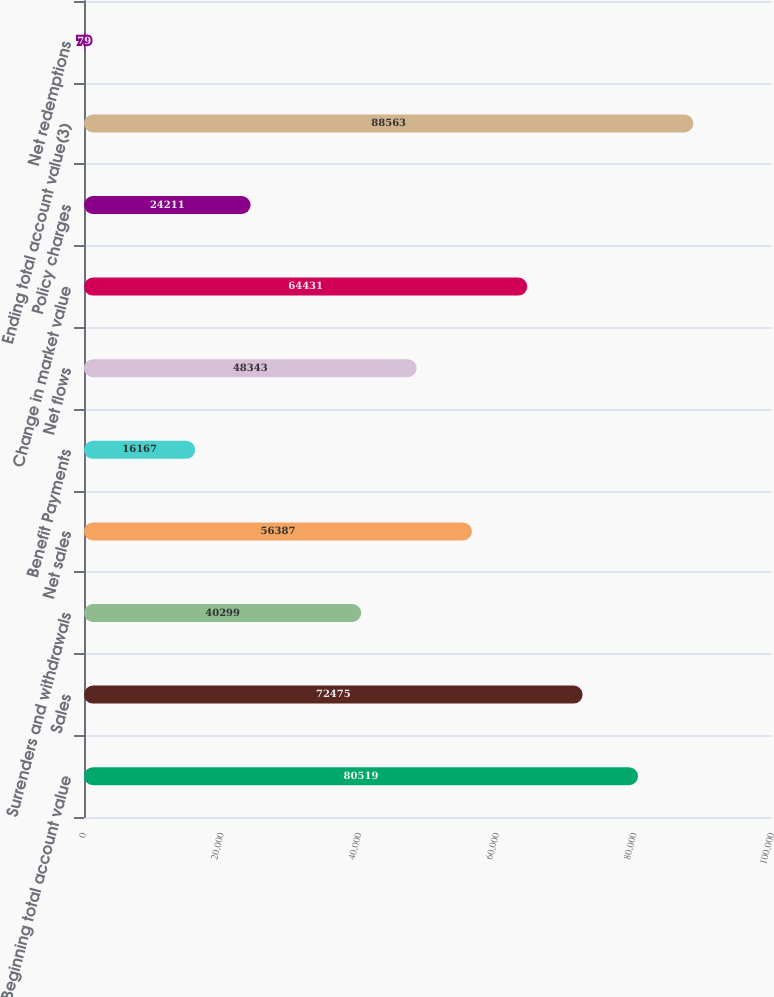Convert chart. <chart><loc_0><loc_0><loc_500><loc_500><bar_chart><fcel>Beginning total account value<fcel>Sales<fcel>Surrenders and withdrawals<fcel>Net sales<fcel>Benefit Payments<fcel>Net flows<fcel>Change in market value<fcel>Policy charges<fcel>Ending total account value(3)<fcel>Net redemptions<nl><fcel>80519<fcel>72475<fcel>40299<fcel>56387<fcel>16167<fcel>48343<fcel>64431<fcel>24211<fcel>88563<fcel>79<nl></chart> 